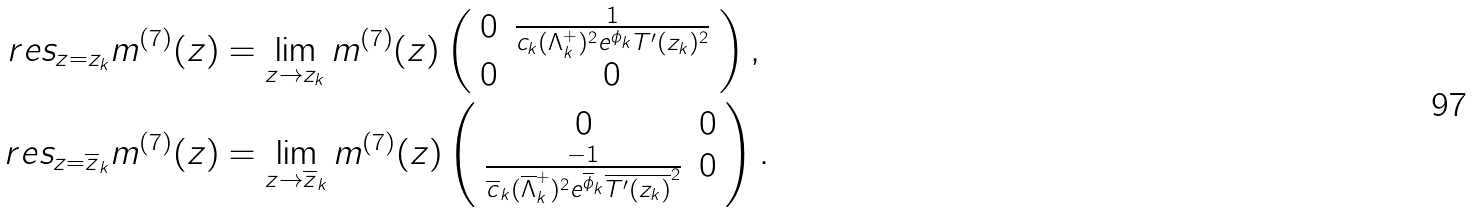<formula> <loc_0><loc_0><loc_500><loc_500>\ r e s _ { z = z _ { k } } m ^ { ( 7 ) } ( z ) & = \lim _ { z \to z _ { k } } m ^ { ( 7 ) } ( z ) \left ( \begin{array} { c c } 0 & \frac { 1 } { c _ { k } ( \Lambda _ { k } ^ { + } ) ^ { 2 } e ^ { \phi _ { k } } T ^ { \prime } ( z _ { k } ) ^ { 2 } } \\ 0 & 0 \end{array} \right ) , \\ \ r e s _ { z = \overline { z } _ { k } } m ^ { ( 7 ) } ( z ) & = \lim _ { z \to \overline { z } _ { k } } m ^ { ( 7 ) } ( z ) \left ( \begin{array} { c c } 0 & 0 \\ \frac { - 1 } { \overline { c } _ { k } ( \overline { \Lambda } _ { k } ^ { + } ) ^ { 2 } e ^ { \overline { \phi } _ { k } } \overline { T ^ { \prime } ( z _ { k } ) } ^ { 2 } } & 0 \end{array} \right ) .</formula> 